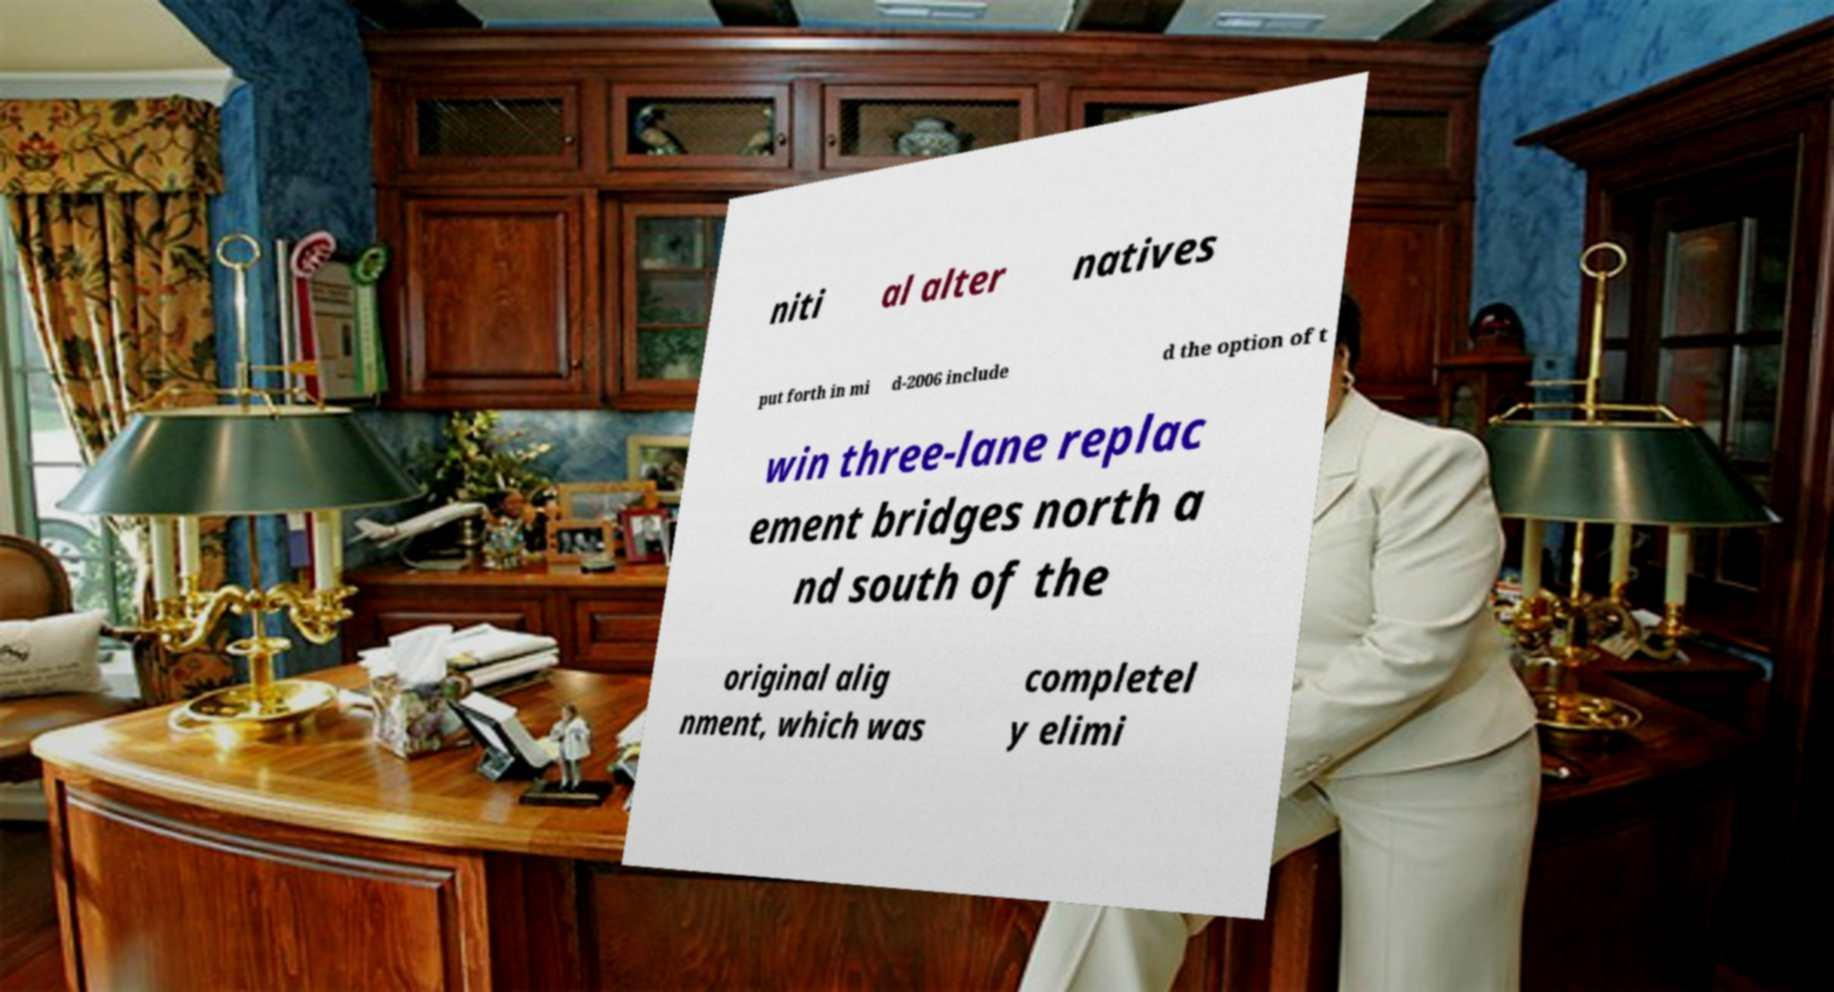I need the written content from this picture converted into text. Can you do that? niti al alter natives put forth in mi d-2006 include d the option of t win three-lane replac ement bridges north a nd south of the original alig nment, which was completel y elimi 